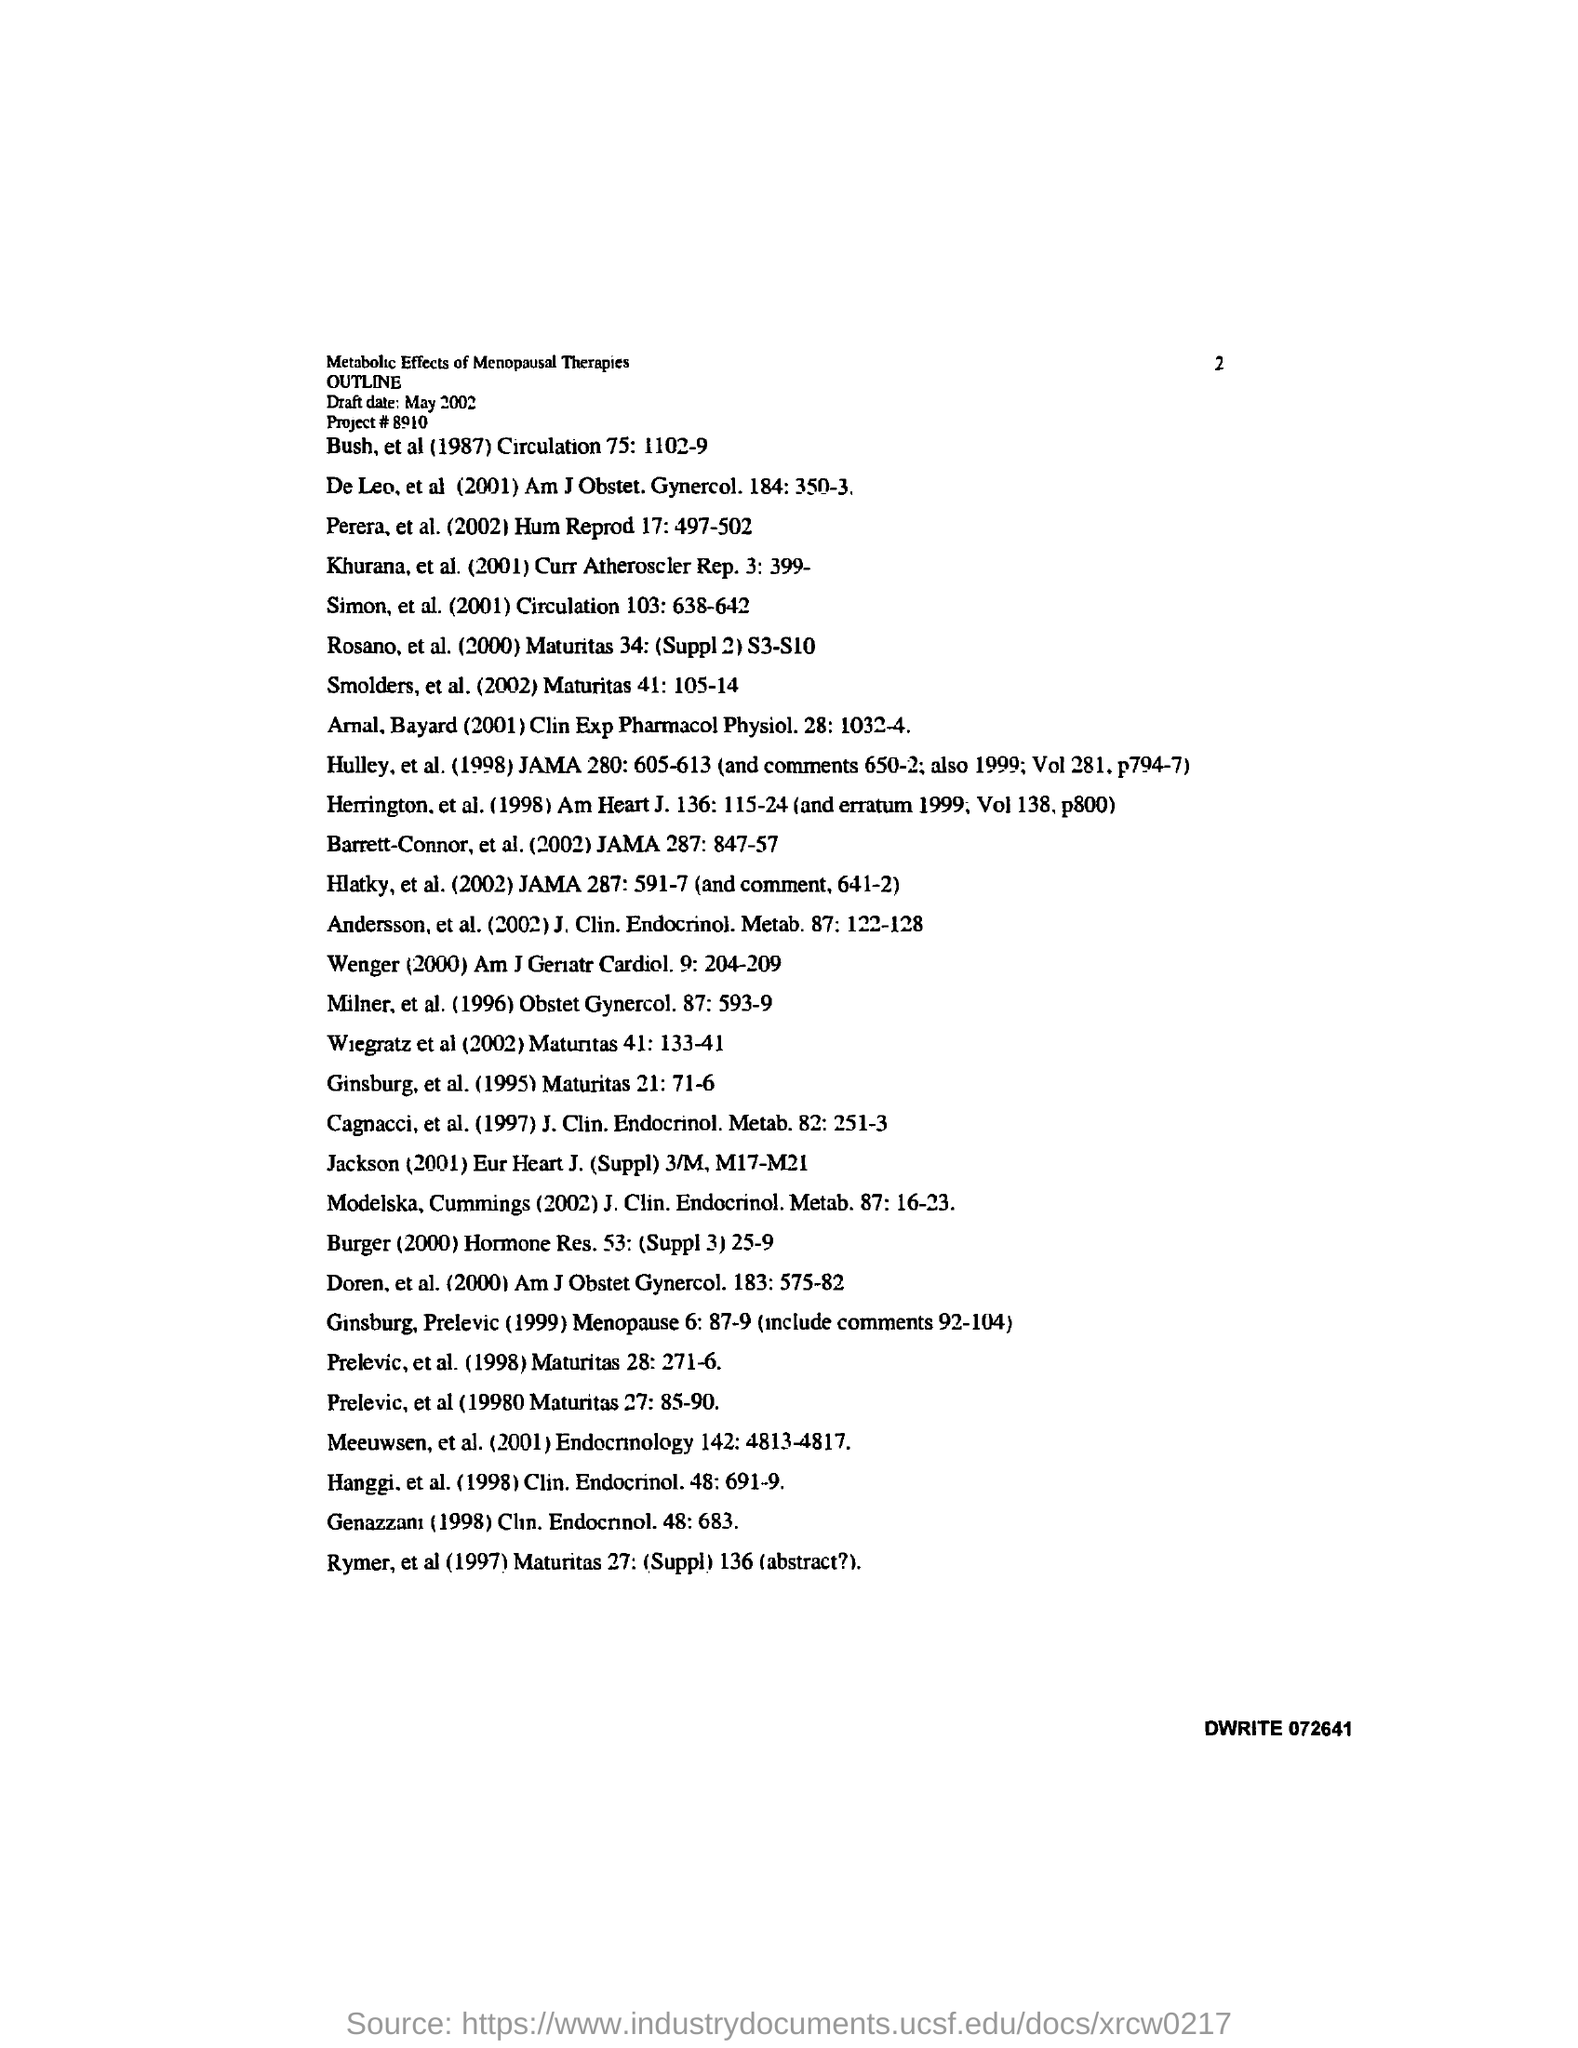Indicate a few pertinent items in this graphic. The document contains a date mentioned as "May 2002. Can you please provide the project number? 